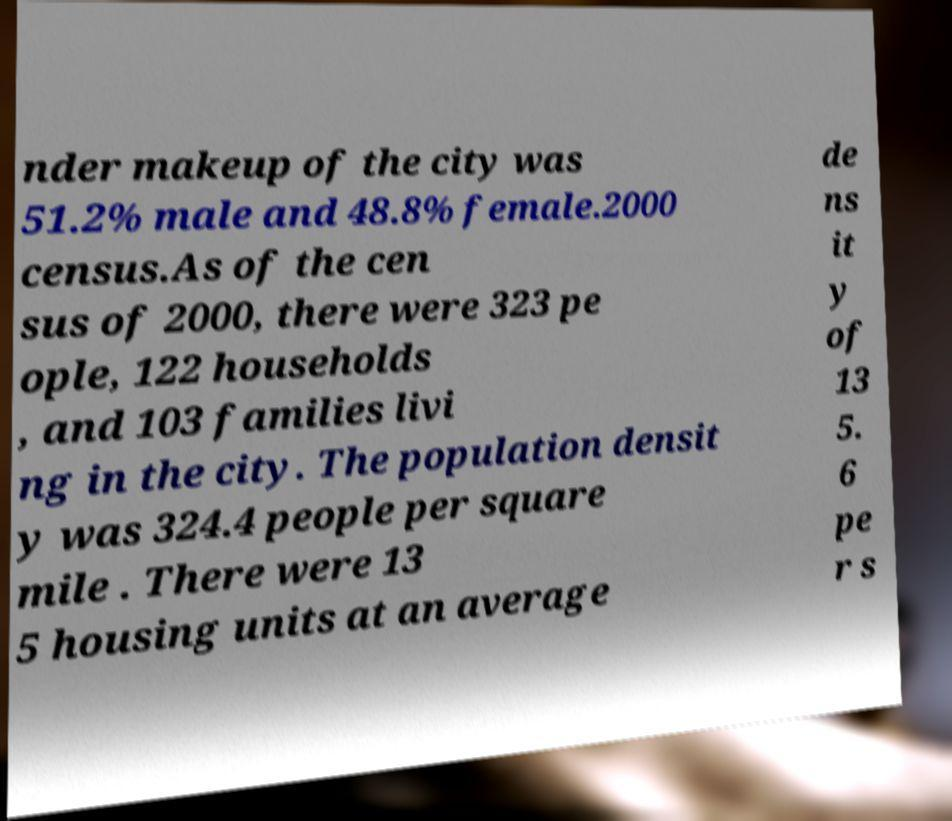I need the written content from this picture converted into text. Can you do that? nder makeup of the city was 51.2% male and 48.8% female.2000 census.As of the cen sus of 2000, there were 323 pe ople, 122 households , and 103 families livi ng in the city. The population densit y was 324.4 people per square mile . There were 13 5 housing units at an average de ns it y of 13 5. 6 pe r s 